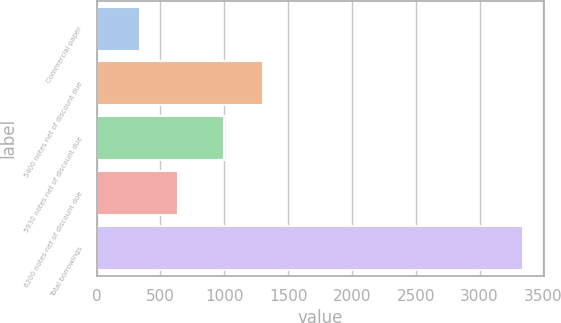<chart> <loc_0><loc_0><loc_500><loc_500><bar_chart><fcel>Commercial paper<fcel>5400 notes net of discount due<fcel>5930 notes net of discount due<fcel>6200 notes net of discount due<fcel>Total borrowings<nl><fcel>338.2<fcel>1299.68<fcel>999.7<fcel>638.18<fcel>3338<nl></chart> 